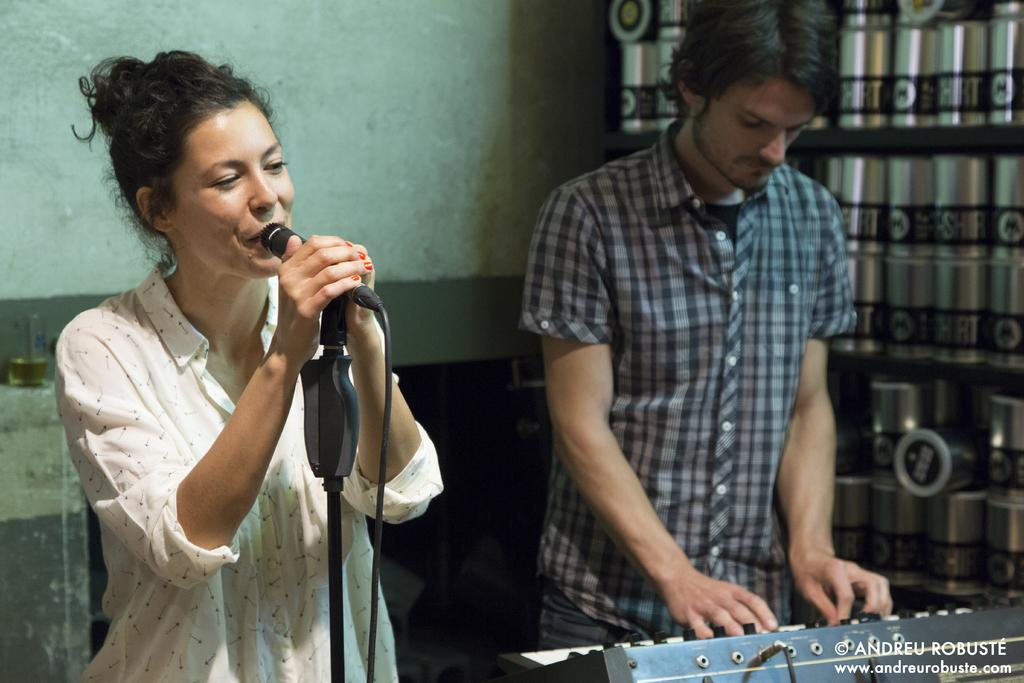Who is the main subject in the image? There is a woman in the image. What is the woman doing in the image? The woman is in front of a mic. Who else is present in the image? There is a man in the image. What is the man doing in the image? The man is standing and has his hands on a keyboard. What can be seen in the background of the image? There is a wall in the background of the image. What type of loaf is being prepared by the woman in the image? There is no loaf present in the image; the woman is in front of a mic. Can you tell me how many needles are visible in the image? There are no needles present in the image. 